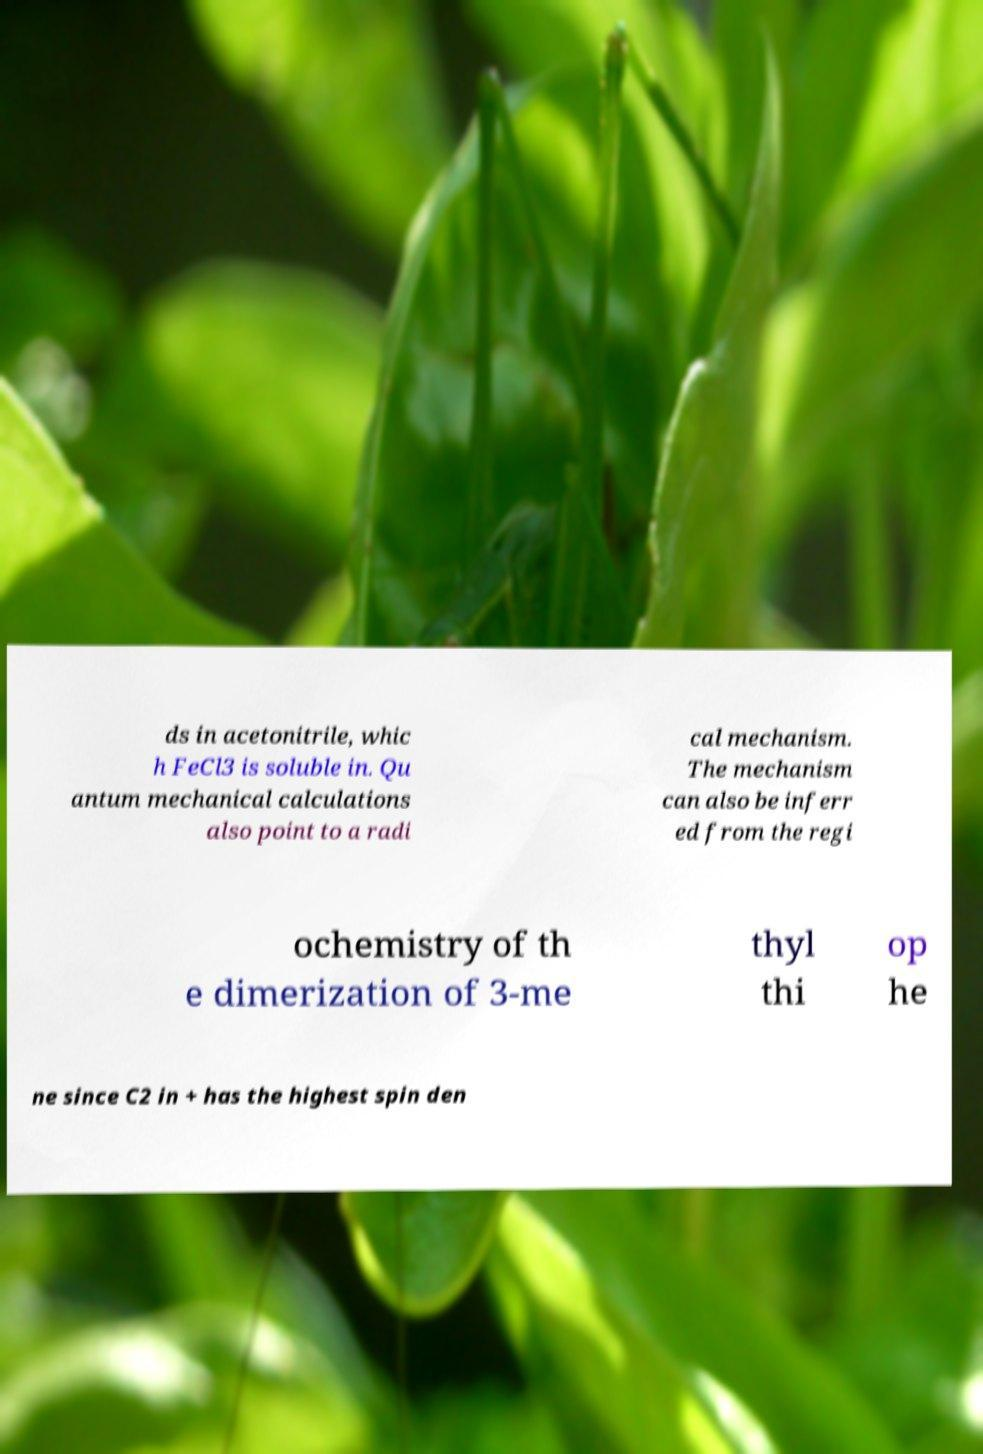There's text embedded in this image that I need extracted. Can you transcribe it verbatim? ds in acetonitrile, whic h FeCl3 is soluble in. Qu antum mechanical calculations also point to a radi cal mechanism. The mechanism can also be inferr ed from the regi ochemistry of th e dimerization of 3-me thyl thi op he ne since C2 in + has the highest spin den 